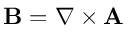Convert formula to latex. <formula><loc_0><loc_0><loc_500><loc_500>{ B } = \nabla \times { A }</formula> 